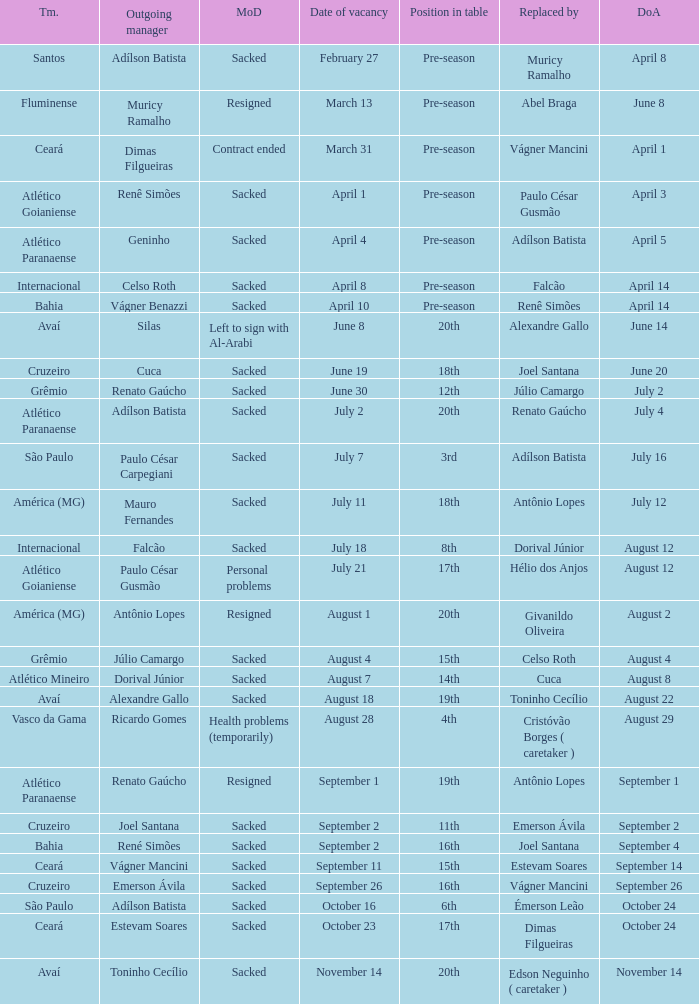What team hired Renato Gaúcho? Atlético Paranaense. 